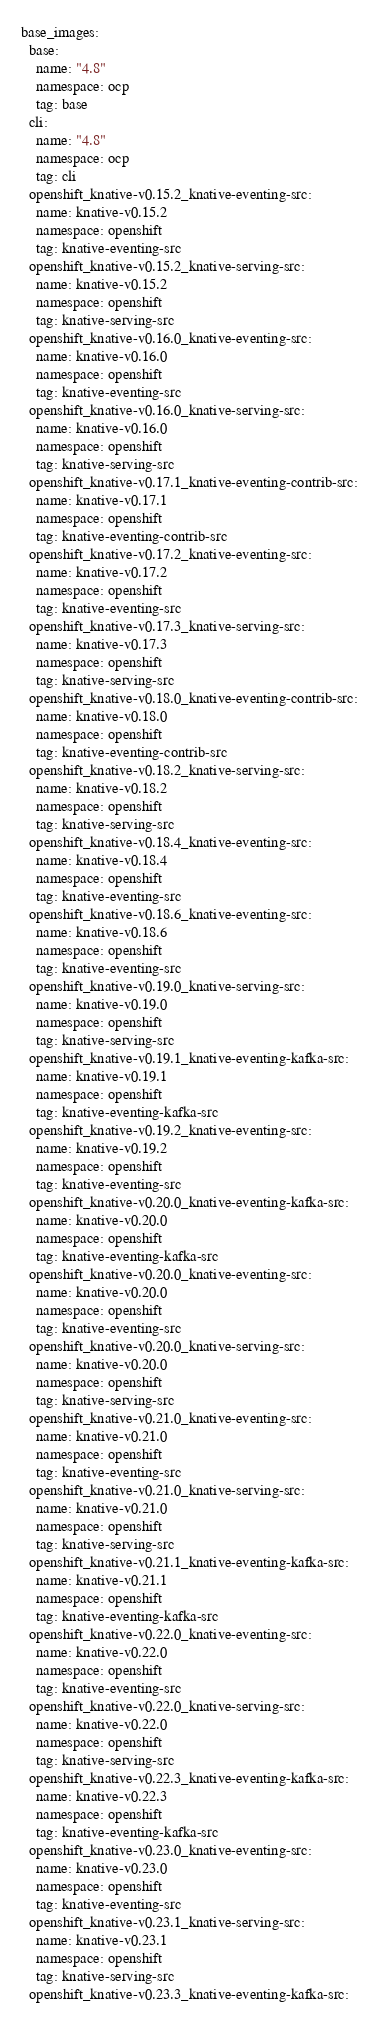Convert code to text. <code><loc_0><loc_0><loc_500><loc_500><_YAML_>base_images:
  base:
    name: "4.8"
    namespace: ocp
    tag: base
  cli:
    name: "4.8"
    namespace: ocp
    tag: cli
  openshift_knative-v0.15.2_knative-eventing-src:
    name: knative-v0.15.2
    namespace: openshift
    tag: knative-eventing-src
  openshift_knative-v0.15.2_knative-serving-src:
    name: knative-v0.15.2
    namespace: openshift
    tag: knative-serving-src
  openshift_knative-v0.16.0_knative-eventing-src:
    name: knative-v0.16.0
    namespace: openshift
    tag: knative-eventing-src
  openshift_knative-v0.16.0_knative-serving-src:
    name: knative-v0.16.0
    namespace: openshift
    tag: knative-serving-src
  openshift_knative-v0.17.1_knative-eventing-contrib-src:
    name: knative-v0.17.1
    namespace: openshift
    tag: knative-eventing-contrib-src
  openshift_knative-v0.17.2_knative-eventing-src:
    name: knative-v0.17.2
    namespace: openshift
    tag: knative-eventing-src
  openshift_knative-v0.17.3_knative-serving-src:
    name: knative-v0.17.3
    namespace: openshift
    tag: knative-serving-src
  openshift_knative-v0.18.0_knative-eventing-contrib-src:
    name: knative-v0.18.0
    namespace: openshift
    tag: knative-eventing-contrib-src
  openshift_knative-v0.18.2_knative-serving-src:
    name: knative-v0.18.2
    namespace: openshift
    tag: knative-serving-src
  openshift_knative-v0.18.4_knative-eventing-src:
    name: knative-v0.18.4
    namespace: openshift
    tag: knative-eventing-src
  openshift_knative-v0.18.6_knative-eventing-src:
    name: knative-v0.18.6
    namespace: openshift
    tag: knative-eventing-src
  openshift_knative-v0.19.0_knative-serving-src:
    name: knative-v0.19.0
    namespace: openshift
    tag: knative-serving-src
  openshift_knative-v0.19.1_knative-eventing-kafka-src:
    name: knative-v0.19.1
    namespace: openshift
    tag: knative-eventing-kafka-src
  openshift_knative-v0.19.2_knative-eventing-src:
    name: knative-v0.19.2
    namespace: openshift
    tag: knative-eventing-src
  openshift_knative-v0.20.0_knative-eventing-kafka-src:
    name: knative-v0.20.0
    namespace: openshift
    tag: knative-eventing-kafka-src
  openshift_knative-v0.20.0_knative-eventing-src:
    name: knative-v0.20.0
    namespace: openshift
    tag: knative-eventing-src
  openshift_knative-v0.20.0_knative-serving-src:
    name: knative-v0.20.0
    namespace: openshift
    tag: knative-serving-src
  openshift_knative-v0.21.0_knative-eventing-src:
    name: knative-v0.21.0
    namespace: openshift
    tag: knative-eventing-src
  openshift_knative-v0.21.0_knative-serving-src:
    name: knative-v0.21.0
    namespace: openshift
    tag: knative-serving-src
  openshift_knative-v0.21.1_knative-eventing-kafka-src:
    name: knative-v0.21.1
    namespace: openshift
    tag: knative-eventing-kafka-src
  openshift_knative-v0.22.0_knative-eventing-src:
    name: knative-v0.22.0
    namespace: openshift
    tag: knative-eventing-src
  openshift_knative-v0.22.0_knative-serving-src:
    name: knative-v0.22.0
    namespace: openshift
    tag: knative-serving-src
  openshift_knative-v0.22.3_knative-eventing-kafka-src:
    name: knative-v0.22.3
    namespace: openshift
    tag: knative-eventing-kafka-src
  openshift_knative-v0.23.0_knative-eventing-src:
    name: knative-v0.23.0
    namespace: openshift
    tag: knative-eventing-src
  openshift_knative-v0.23.1_knative-serving-src:
    name: knative-v0.23.1
    namespace: openshift
    tag: knative-serving-src
  openshift_knative-v0.23.3_knative-eventing-kafka-src:</code> 